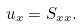Convert formula to latex. <formula><loc_0><loc_0><loc_500><loc_500>u _ { x } = S _ { x x } .</formula> 